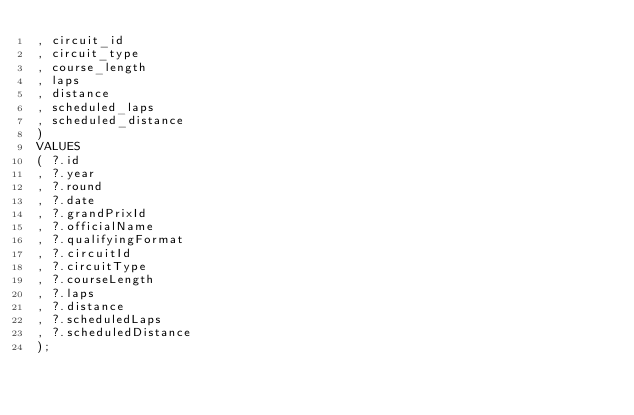<code> <loc_0><loc_0><loc_500><loc_500><_SQL_>, circuit_id
, circuit_type
, course_length
, laps
, distance
, scheduled_laps
, scheduled_distance
)
VALUES
( ?.id
, ?.year
, ?.round
, ?.date
, ?.grandPrixId
, ?.officialName
, ?.qualifyingFormat
, ?.circuitId
, ?.circuitType
, ?.courseLength
, ?.laps
, ?.distance
, ?.scheduledLaps
, ?.scheduledDistance
);
</code> 